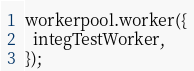Convert code to text. <code><loc_0><loc_0><loc_500><loc_500><_TypeScript_>workerpool.worker({
  integTestWorker,
});

</code> 